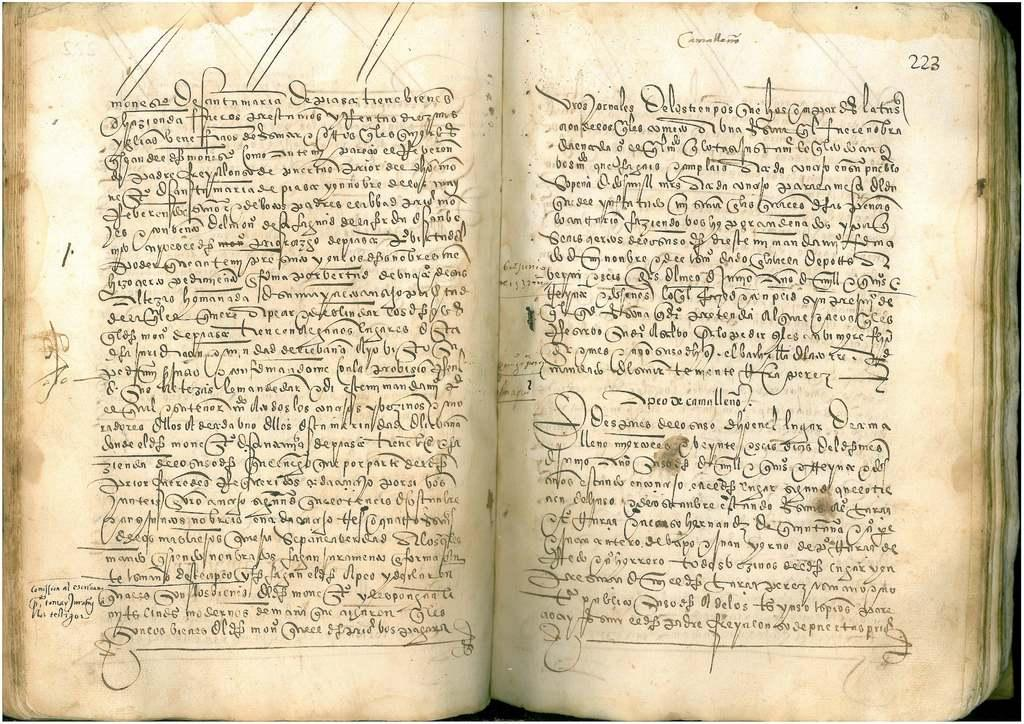<image>
Describe the image concisely. An old book that is opened to page 222 and 223. 